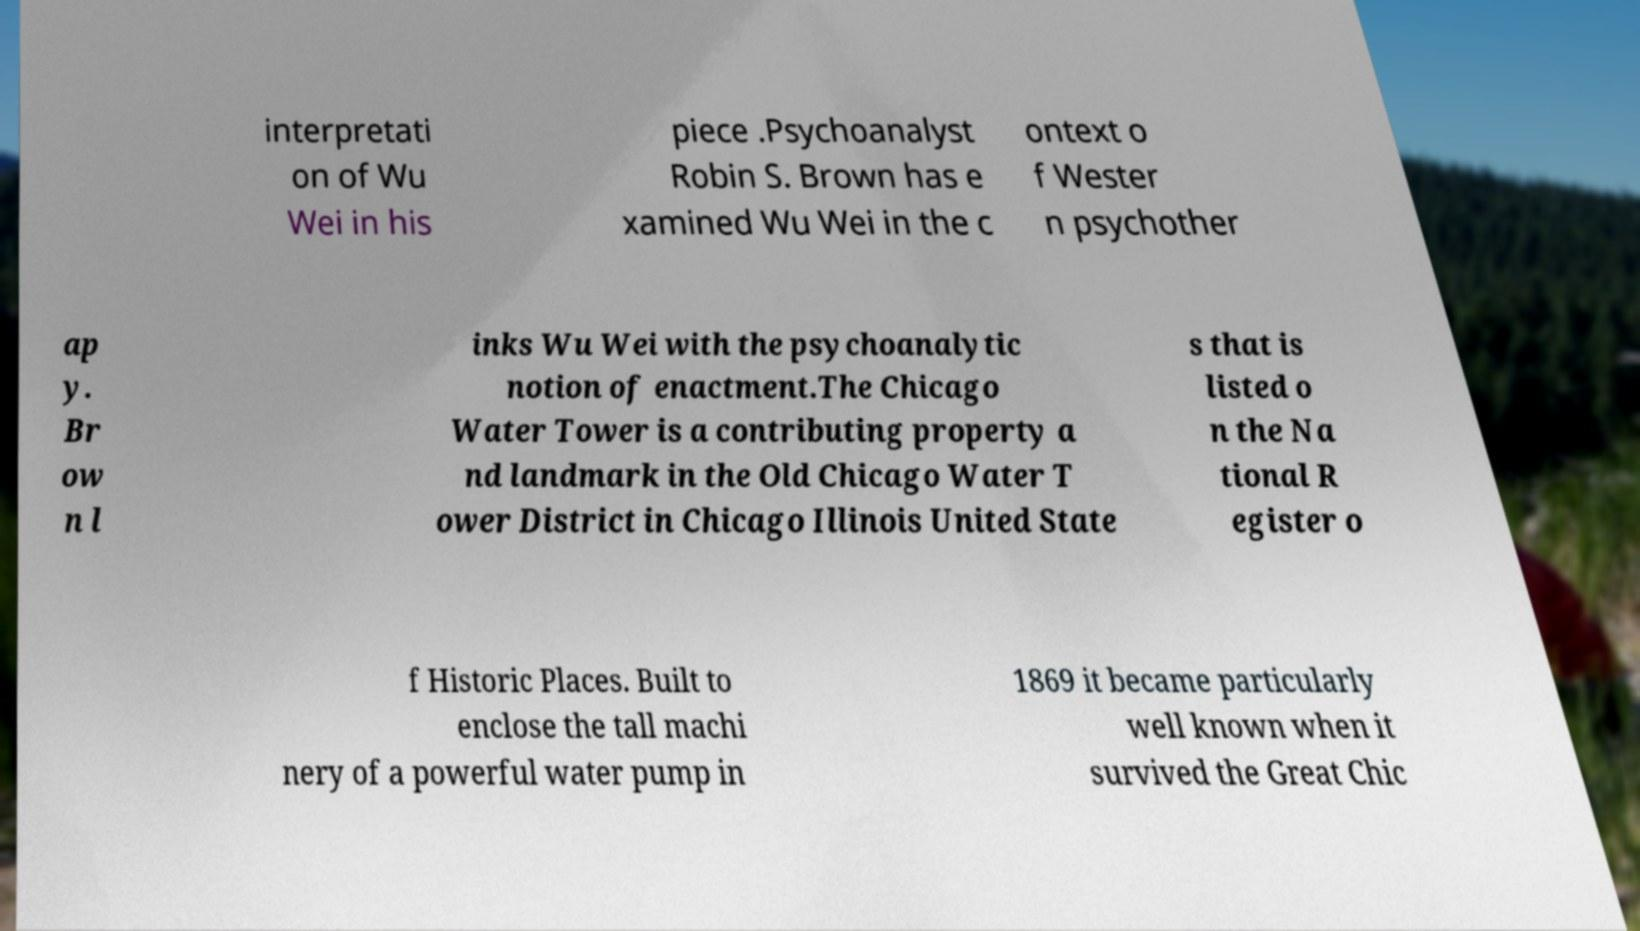Could you assist in decoding the text presented in this image and type it out clearly? interpretati on of Wu Wei in his piece .Psychoanalyst Robin S. Brown has e xamined Wu Wei in the c ontext o f Wester n psychother ap y. Br ow n l inks Wu Wei with the psychoanalytic notion of enactment.The Chicago Water Tower is a contributing property a nd landmark in the Old Chicago Water T ower District in Chicago Illinois United State s that is listed o n the Na tional R egister o f Historic Places. Built to enclose the tall machi nery of a powerful water pump in 1869 it became particularly well known when it survived the Great Chic 